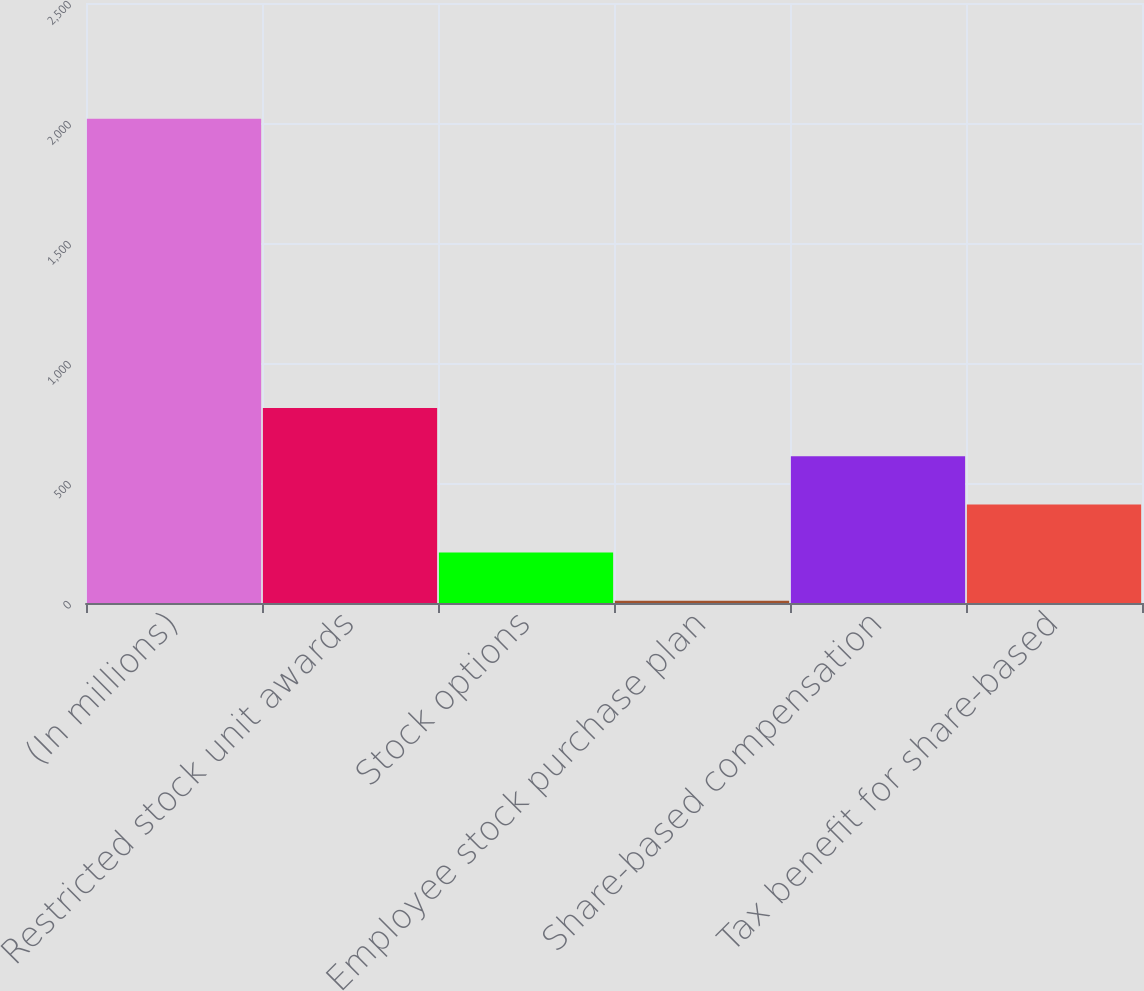Convert chart to OTSL. <chart><loc_0><loc_0><loc_500><loc_500><bar_chart><fcel>(In millions)<fcel>Restricted stock unit awards<fcel>Stock options<fcel>Employee stock purchase plan<fcel>Share-based compensation<fcel>Tax benefit for share-based<nl><fcel>2018<fcel>812.6<fcel>209.9<fcel>9<fcel>611.7<fcel>410.8<nl></chart> 